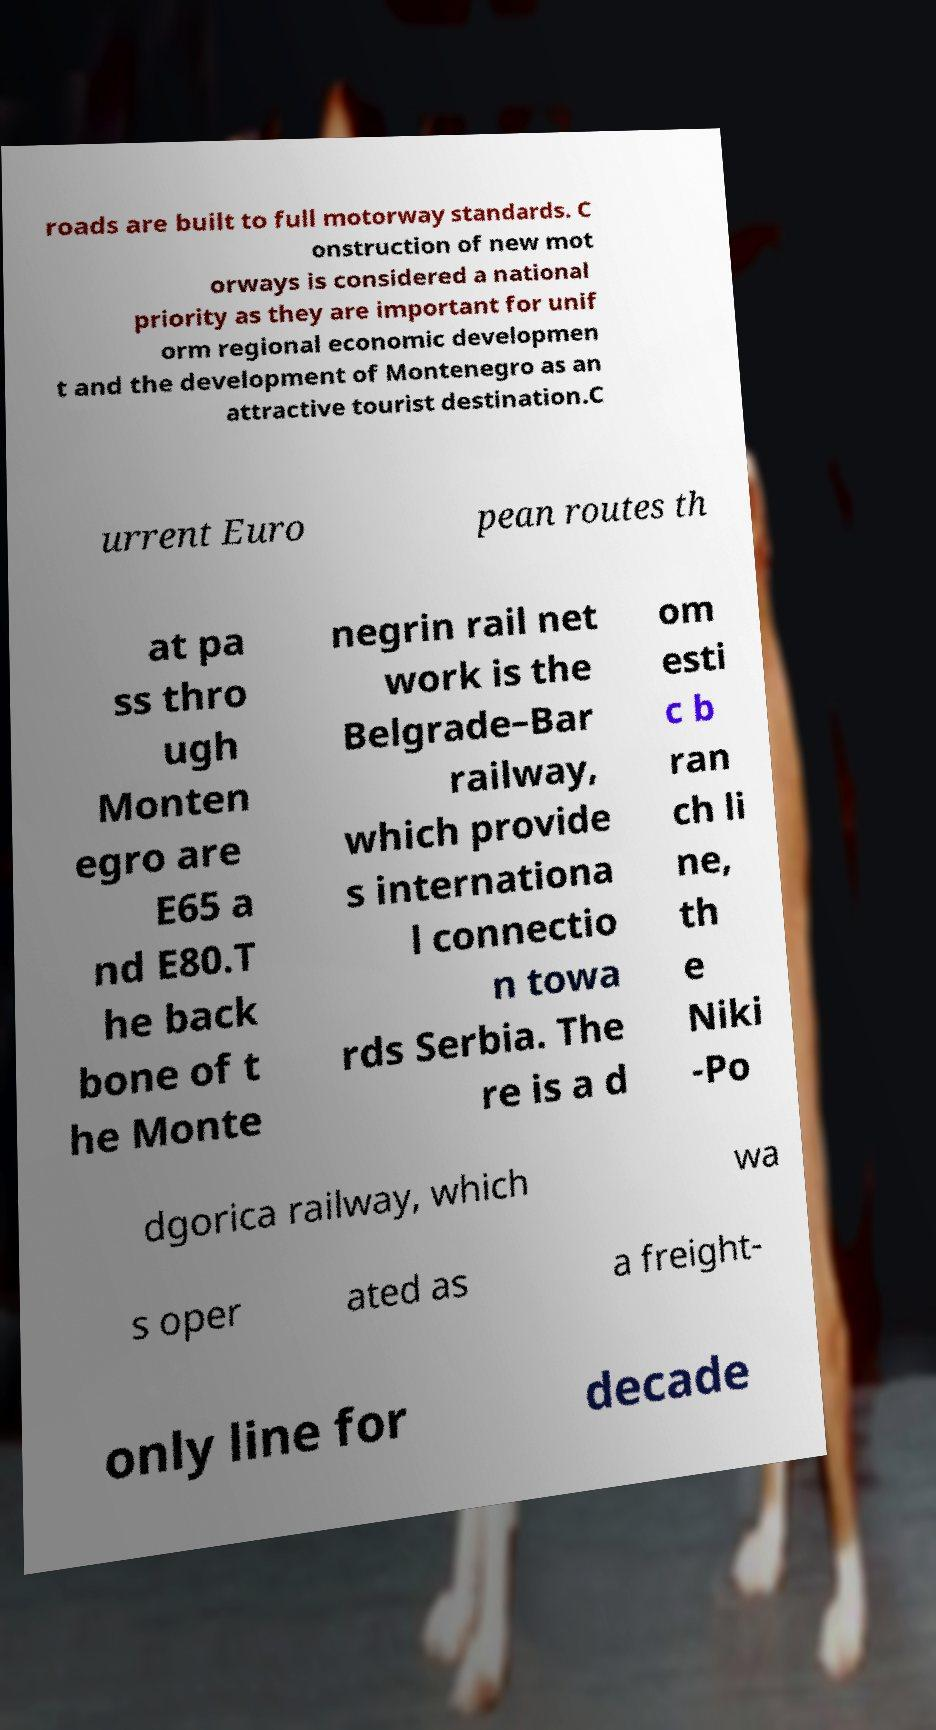Please read and relay the text visible in this image. What does it say? roads are built to full motorway standards. C onstruction of new mot orways is considered a national priority as they are important for unif orm regional economic developmen t and the development of Montenegro as an attractive tourist destination.C urrent Euro pean routes th at pa ss thro ugh Monten egro are E65 a nd E80.T he back bone of t he Monte negrin rail net work is the Belgrade–Bar railway, which provide s internationa l connectio n towa rds Serbia. The re is a d om esti c b ran ch li ne, th e Niki -Po dgorica railway, which wa s oper ated as a freight- only line for decade 